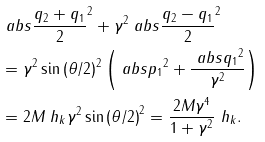<formula> <loc_0><loc_0><loc_500><loc_500>& \ a b s { \frac { q _ { 2 } + q _ { 1 } } { 2 } } ^ { 2 } + \gamma ^ { 2 } \ a b s { \frac { q _ { 2 } - q _ { 1 } } { 2 } } ^ { 2 } \\ & = \gamma ^ { 2 } \sin \left ( \theta / 2 \right ) ^ { 2 } \left ( \ a b s { p _ { 1 } } ^ { 2 } + \frac { \ a b s { q _ { 1 } } ^ { 2 } } { \gamma ^ { 2 } } \right ) \\ & = 2 M \ h _ { k } \gamma ^ { 2 } \sin \left ( \theta / 2 \right ) ^ { 2 } = \frac { 2 M \gamma ^ { 4 } } { 1 + \gamma ^ { 2 } } \ h _ { k } .</formula> 